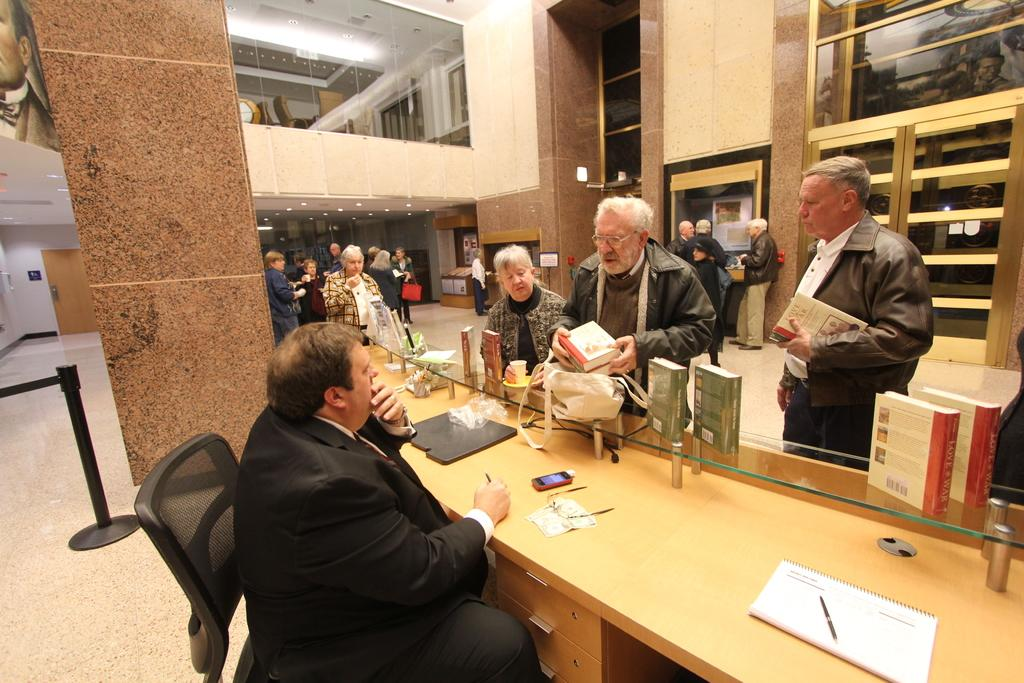What type of structure is visible in the image? There is a building in the image. What are the people in the building doing? There are multiple persons standing in the building, and one person is sitting. What objects can be seen on the table in the building? There are spectacles, a phone, and a book on the table. Can you tell me how many ducks are visible in the image? There are no ducks present in the image. What type of sign is hanging on the wall in the image? There is no sign visible in the image. 